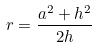<formula> <loc_0><loc_0><loc_500><loc_500>r = \frac { a ^ { 2 } + h ^ { 2 } } { 2 h }</formula> 